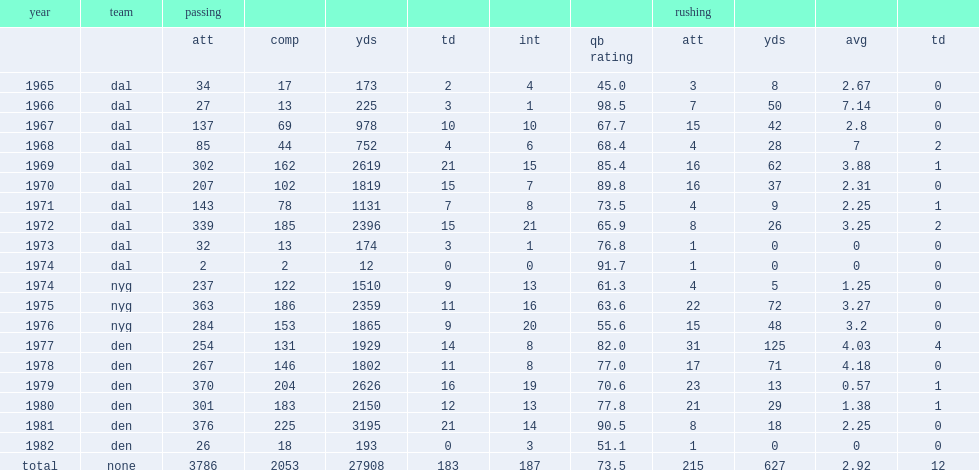How many passing yards did craig morton get in 1972? 2396.0. 